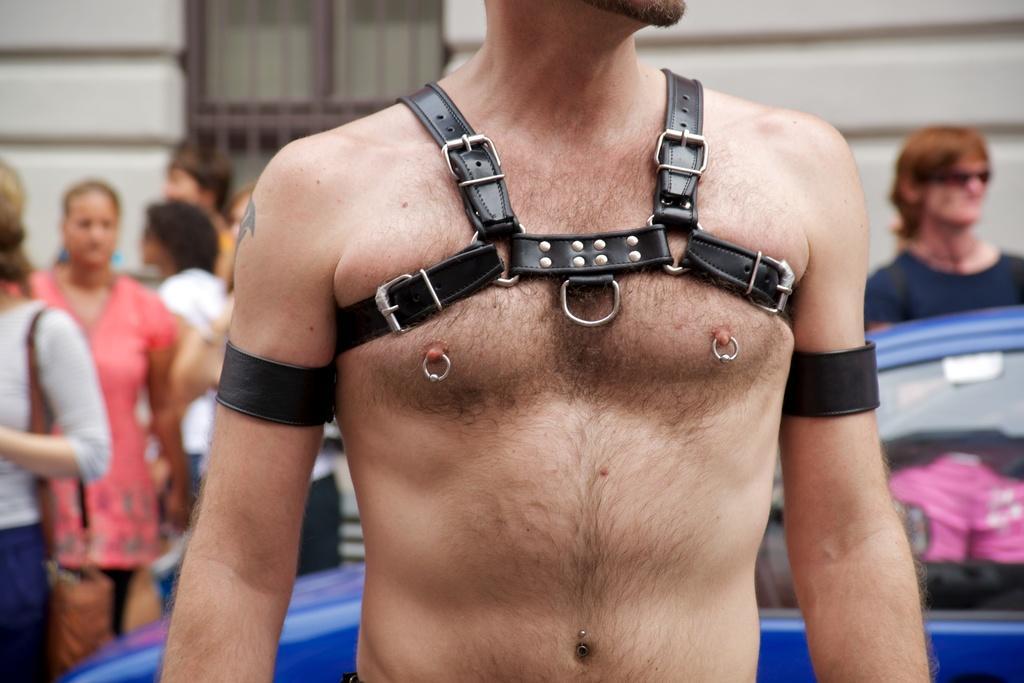Describe this image in one or two sentences. in this picture we see a man standing, he wore a belt and on the back of him, We see a blue car and a human standing and on the left we see few people standing, among them a woman wore a hand bag on the background, we see a wall of a building and a window. 